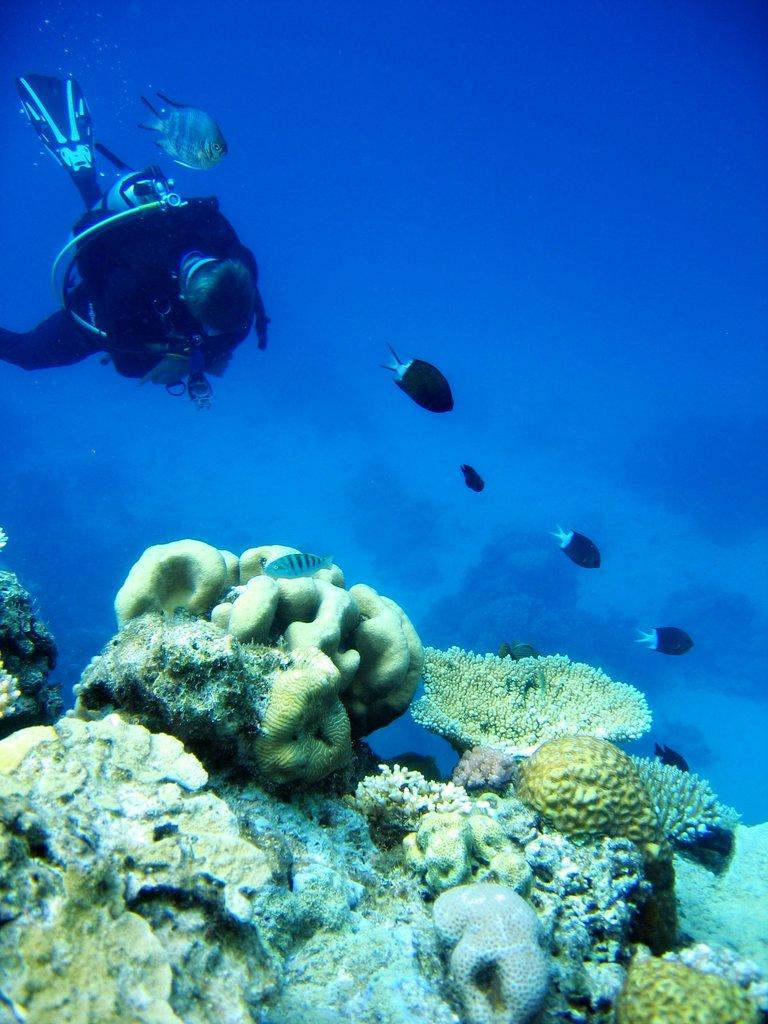What is the person in the image doing? The person is in the water. What protective gear is the person wearing? The person is wearing a helmet, an oxygen cylinder, and gloves. What can be seen in front of the person? There are fishes in front of the person. What is visible at the bottom of the image? There are sea plants at the bottom of the image. What type of lead is the person using to swim in the image? There is no lead present in the image, and the person is not swimming; they are wearing an oxygen cylinder for underwater activity. What is the person using to protect their ears in the image? There is no mention of ear protection in the image; the person is wearing a helmet, gloves, and an oxygen cylinder for underwater activity. 